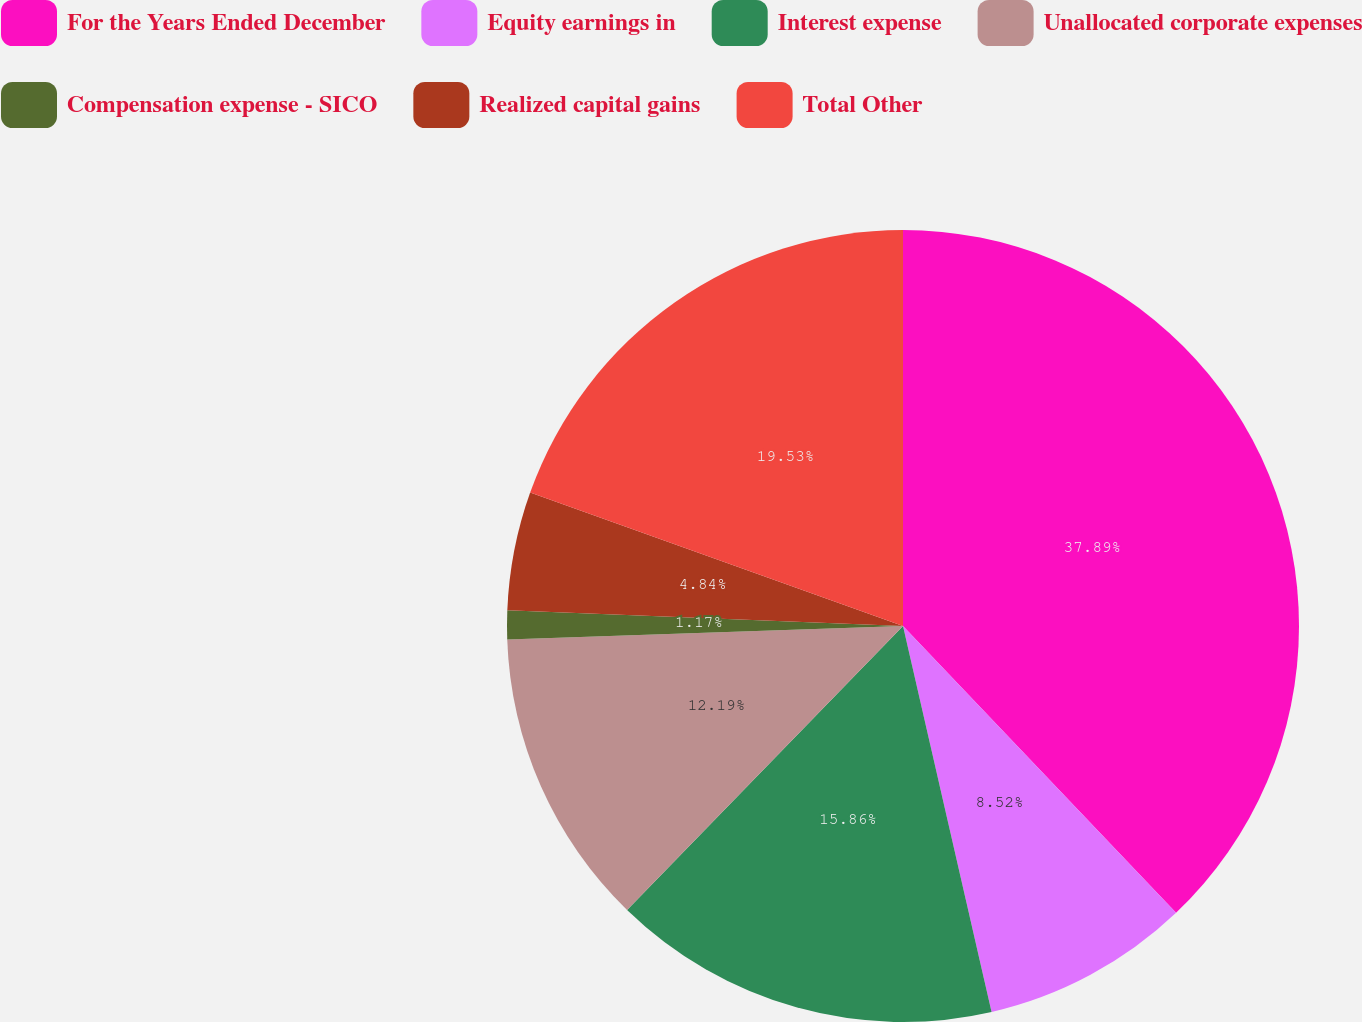<chart> <loc_0><loc_0><loc_500><loc_500><pie_chart><fcel>For the Years Ended December<fcel>Equity earnings in<fcel>Interest expense<fcel>Unallocated corporate expenses<fcel>Compensation expense - SICO<fcel>Realized capital gains<fcel>Total Other<nl><fcel>37.89%<fcel>8.52%<fcel>15.86%<fcel>12.19%<fcel>1.17%<fcel>4.84%<fcel>19.53%<nl></chart> 